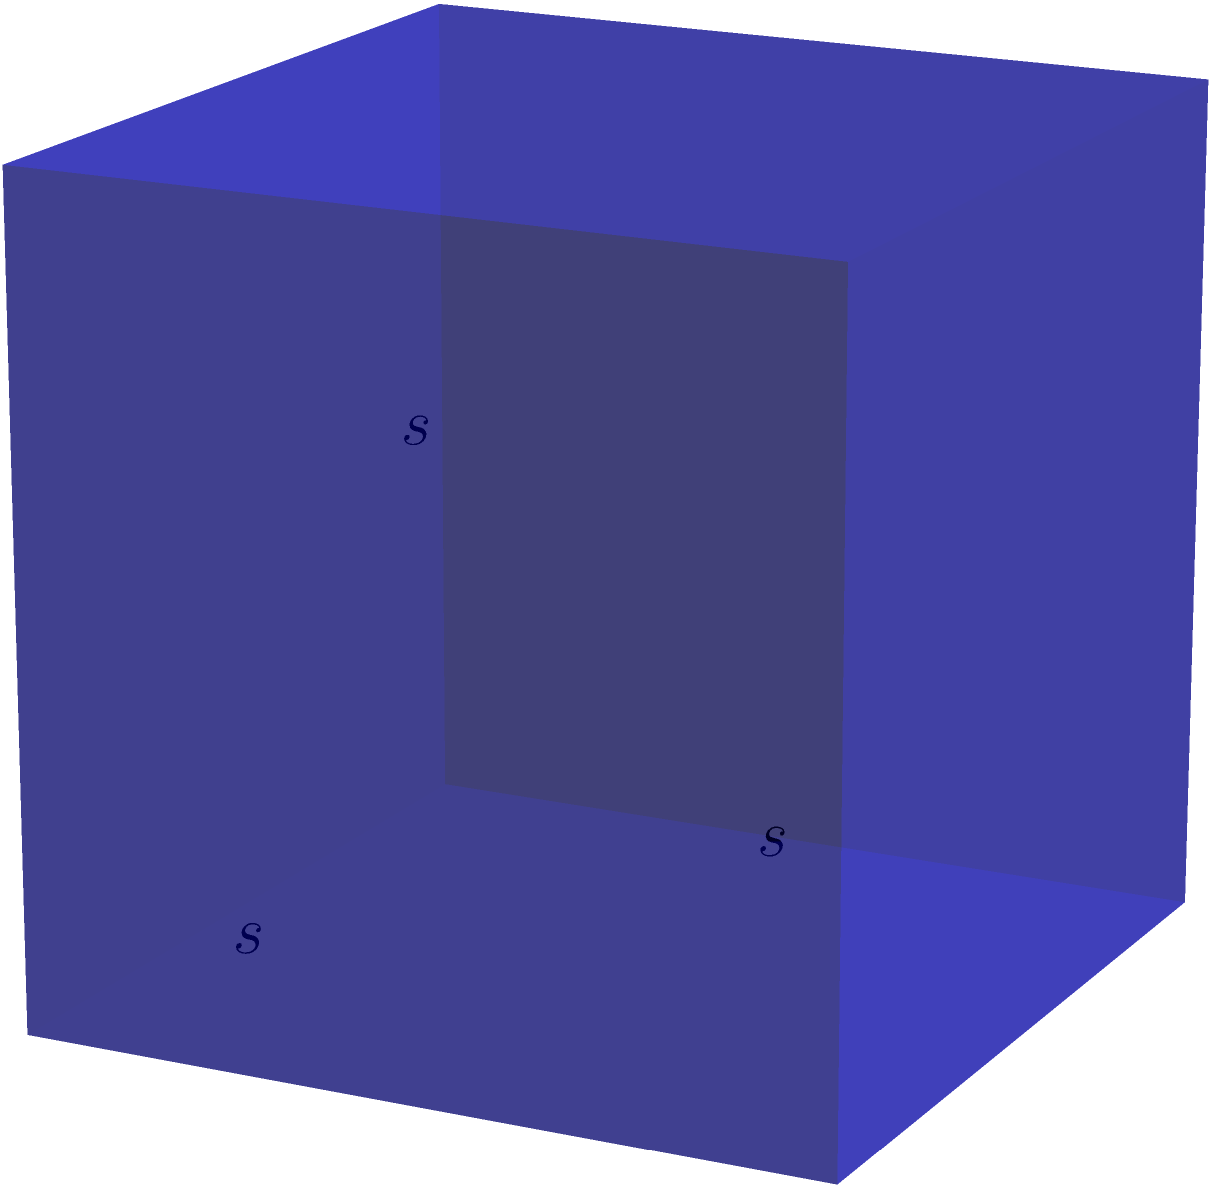In data encryption, the strength of a cryptographic key is often represented by its bit length. Consider a cube where each side represents a 64-bit encryption key. If the total surface area of this cube is 24,576 square bits, calculate the volume of the cube. How many bits of data can this encryption key potentially secure? Let's approach this step-by-step:

1) First, we need to find the side length of the cube. Let's call it $s$.

2) We know that the surface area of a cube is given by the formula:
   $SA = 6s^2$

3) We're given that the surface area is 24,576 square bits. So we can write:
   $24,576 = 6s^2$

4) Solving for $s$:
   $s^2 = 24,576 / 6 = 4,096$
   $s = \sqrt{4,096} = 64$ bits

5) Now that we have the side length, we can calculate the volume. The volume of a cube is given by:
   $V = s^3$

6) Plugging in our value for $s$:
   $V = 64^3 = 262,144$ cubic bits

7) In encryption, this cube represents the key space. Each bit in the volume represents a possible key configuration.

8) Therefore, this 64-bit key can potentially secure $262,144$ bits of data, which is equivalent to $2^{18}$ bits or $2^{64}$ possible key combinations.
Answer: $262,144$ cubic bits 